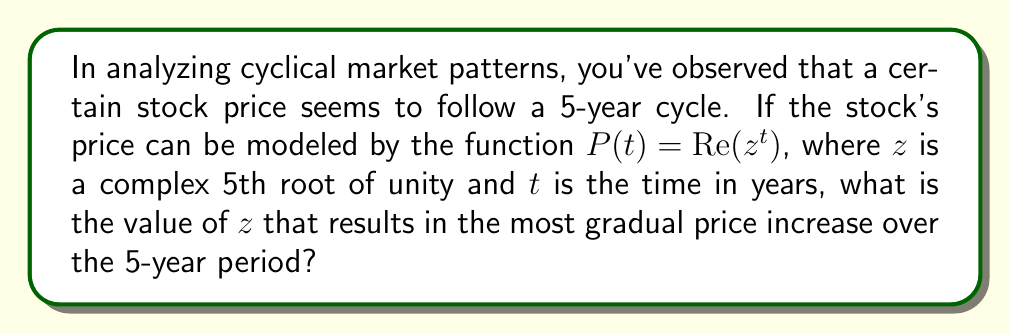Show me your answer to this math problem. Let's approach this step-by-step:

1) The 5th roots of unity are given by the formula:
   $$z_k = e^{2\pi i k / 5}, \quad k = 0, 1, 2, 3, 4$$

2) These roots are:
   $$z_0 = 1$$
   $$z_1 = e^{2\pi i / 5} = \cos(2\pi/5) + i\sin(2\pi/5)$$
   $$z_2 = e^{4\pi i / 5} = \cos(4\pi/5) + i\sin(4\pi/5)$$
   $$z_3 = e^{6\pi i / 5} = \cos(6\pi/5) + i\sin(6\pi/5)$$
   $$z_4 = e^{8\pi i / 5} = \cos(8\pi/5) + i\sin(8\pi/5)$$

3) The price function $P(t) = Re(z^t)$ represents the real part of $z^t$.

4) For the most gradual increase, we want the root that, when raised to increasing powers, rotates around the complex plane most slowly in the counterclockwise direction.

5) This would be $z_1 = e^{2\pi i / 5}$, as it represents the smallest positive angle in the counterclockwise direction.

6) Using Euler's formula, we can express this as:
   $$z_1 = e^{2\pi i / 5} = \cos(2\pi/5) + i\sin(2\pi/5)$$

7) The numerical values are:
   $$z_1 \approx 0.809017 + 0.587785i$$
Answer: $z = e^{2\pi i / 5} \approx 0.809017 + 0.587785i$ 